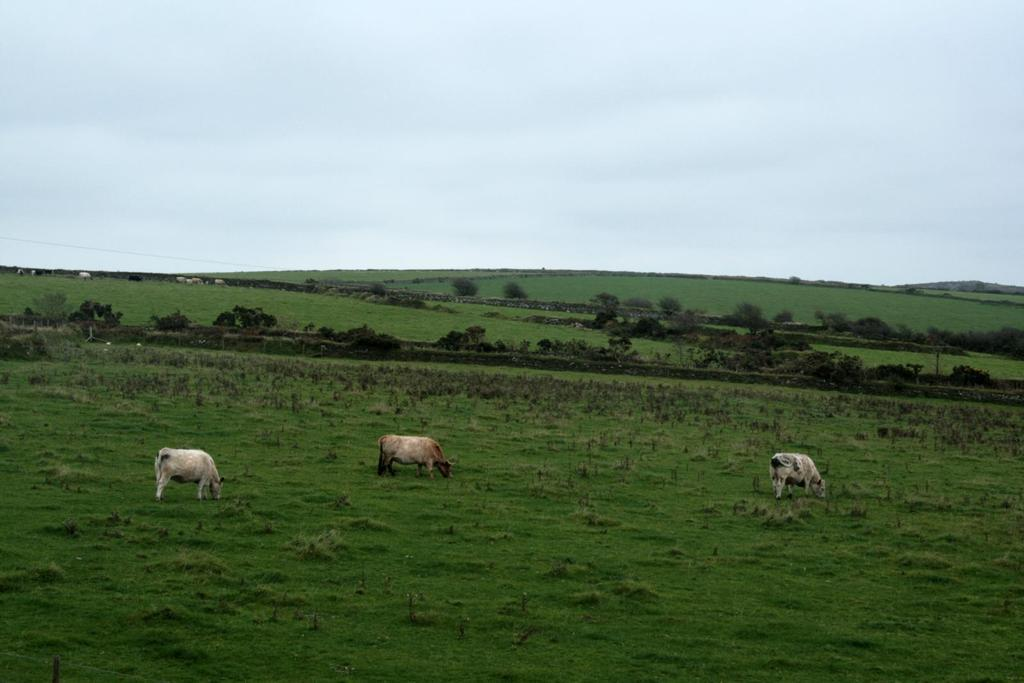What animals are in the center of the image? There are cows in the center of the image. What are the cows doing in the image? The cows are eating grass. What can be seen in the background of the image? There are trees in the background of the image. What is visible at the top of the image? The sky is visible at the top of the image. What type of drug can be seen in the image? There is no drug present in the image; it features cows eating grass with trees and sky in the background. 